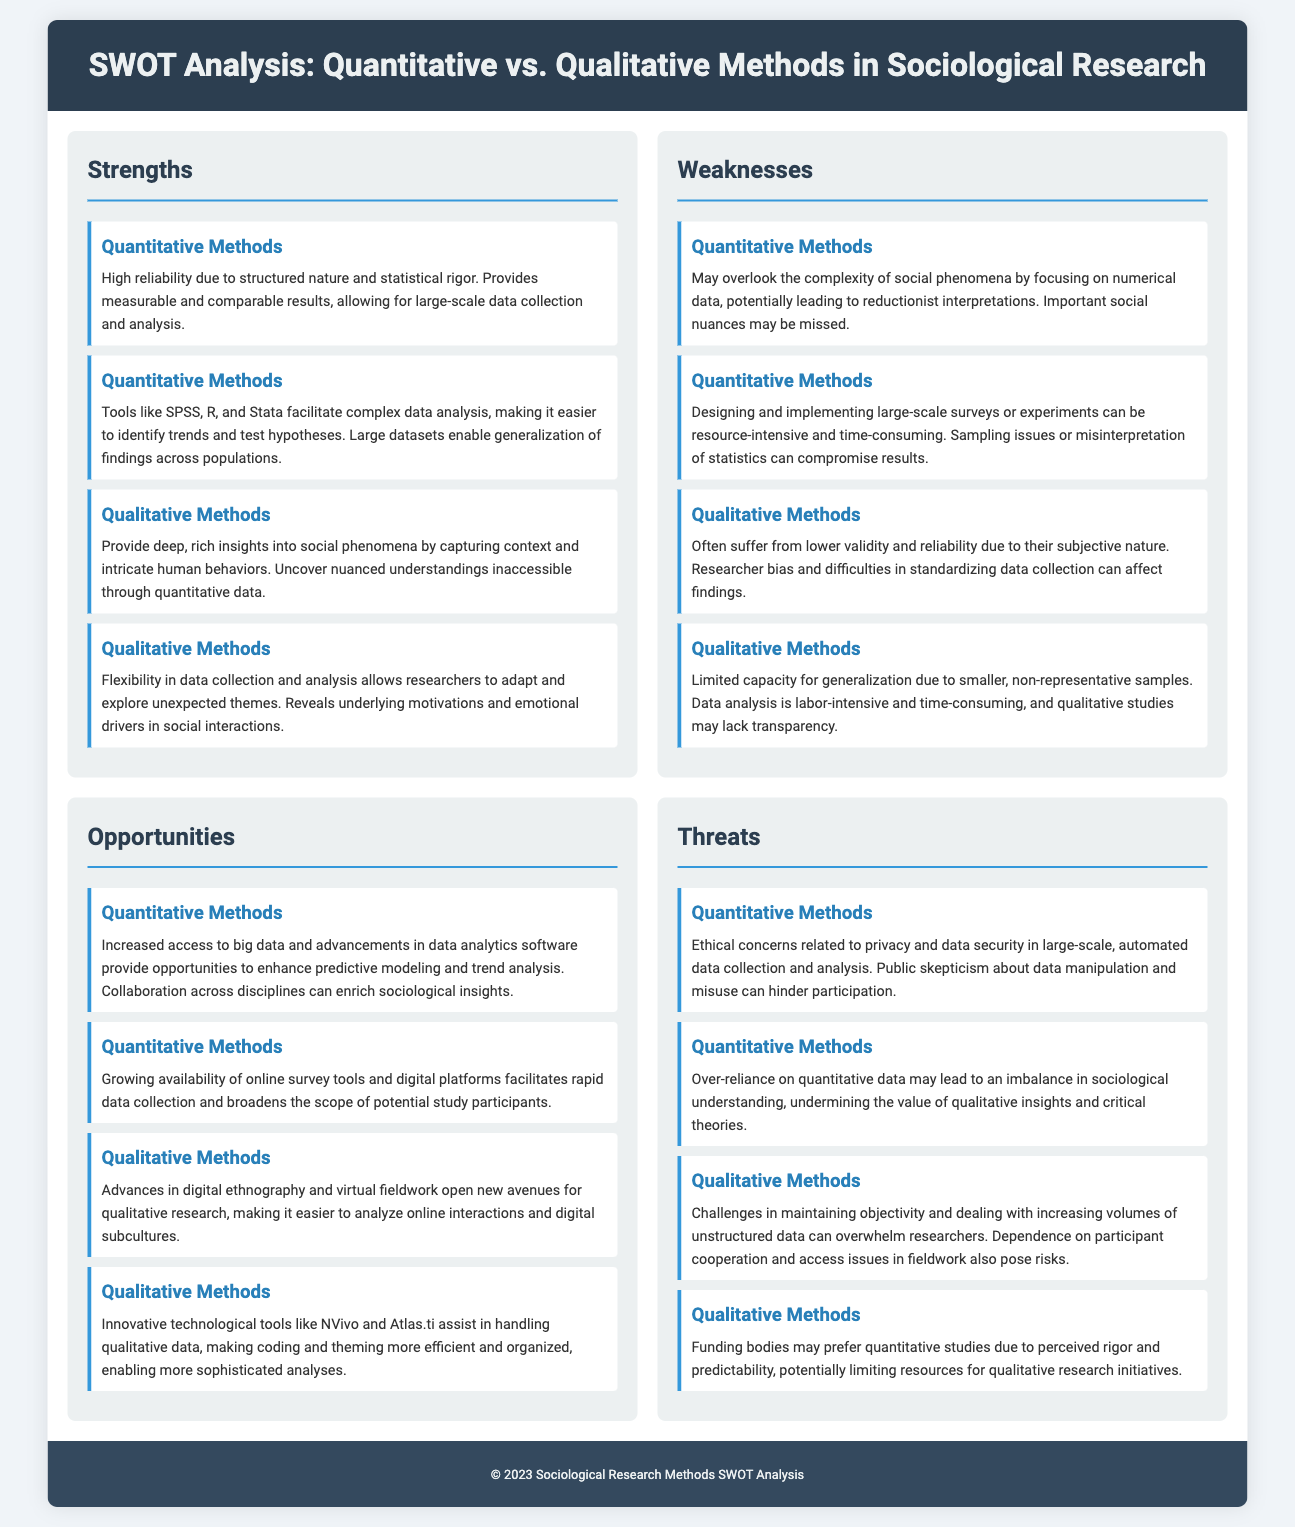What is one strength of quantitative methods? The document lists "High reliability due to structured nature and statistical rigor" as a strength of quantitative methods.
Answer: High reliability due to structured nature and statistical rigor What is a weakness of qualitative methods? The document states that qualitative methods "often suffer from lower validity and reliability due to their subjective nature."
Answer: Lower validity and reliability What opportunity is associated with quantitative methods? The document mentions "Increased access to big data and advancements in data analytics software" as an opportunity for quantitative methods.
Answer: Increased access to big data What is a threat faced by qualitative methods? The document indicates that one threat is "challenges in maintaining objectivity and dealing with increasing volumes of unstructured data."
Answer: Challenges in maintaining objectivity How many strengths are listed for qualitative methods? The document clearly outlines two strengths for qualitative methods, providing insights into social phenomena and flexibility in data collection.
Answer: Two What tools are mentioned that assist in qualitative data handling? The document refers to "NVivo and Atlas.ti" as tools that assist in handling qualitative data.
Answer: NVivo and Atlas.ti What is a concern regarding quantitative methods? The document mentions "ethical concerns related to privacy and data security" as a concern with quantitative methods.
Answer: Ethical concerns related to privacy What factor might limit resources for qualitative research initiatives? The document states that "funding bodies may prefer quantitative studies due to perceived rigor and predictability."
Answer: Preference for quantitative studies 